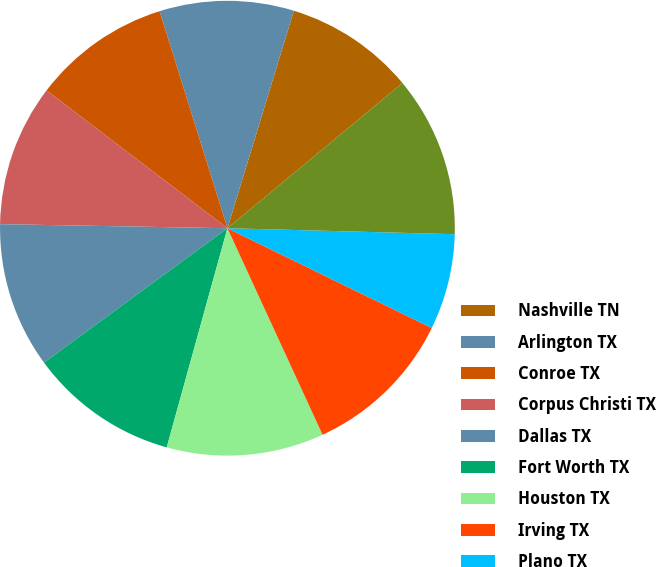<chart> <loc_0><loc_0><loc_500><loc_500><pie_chart><fcel>Nashville TN<fcel>Arlington TX<fcel>Conroe TX<fcel>Corpus Christi TX<fcel>Dallas TX<fcel>Fort Worth TX<fcel>Houston TX<fcel>Irving TX<fcel>Plano TX<fcel>Centerville UT<nl><fcel>9.26%<fcel>9.54%<fcel>9.81%<fcel>10.08%<fcel>10.35%<fcel>10.63%<fcel>11.17%<fcel>10.9%<fcel>6.81%<fcel>11.44%<nl></chart> 